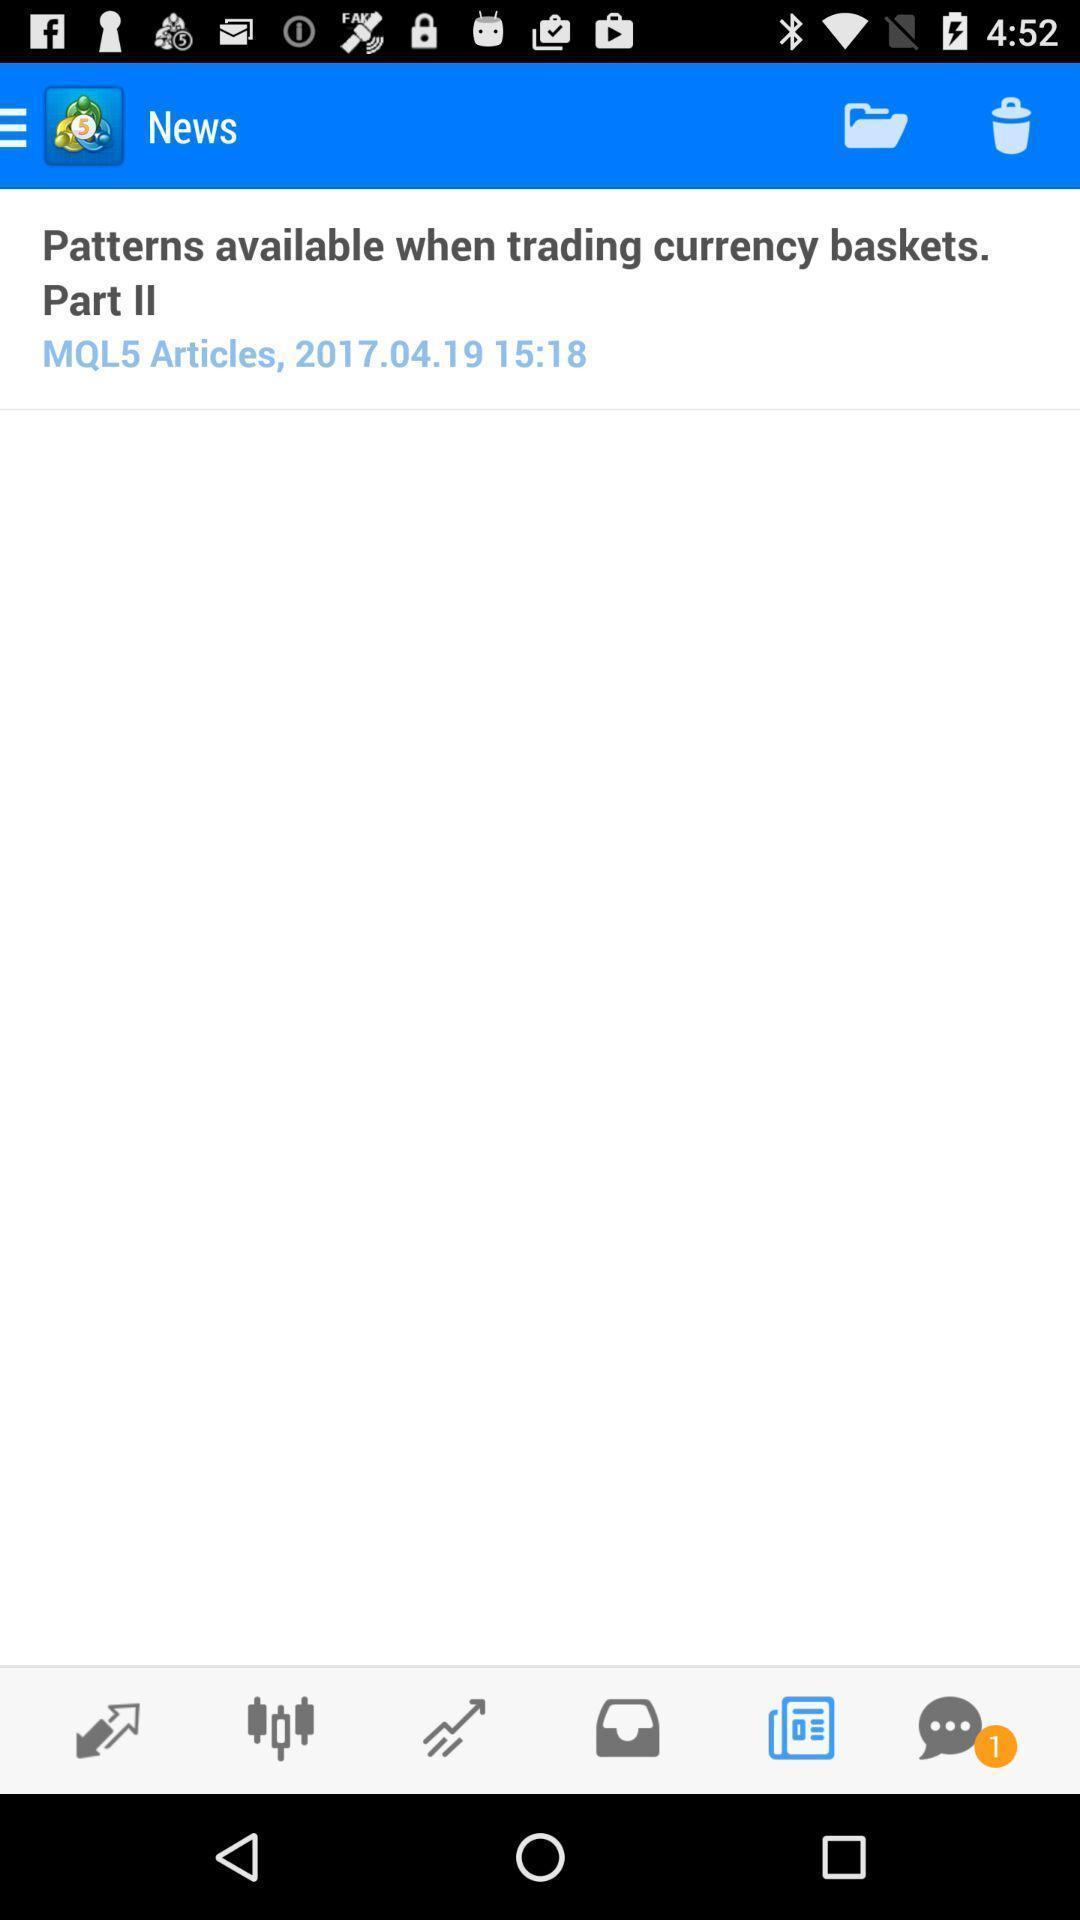Please provide a description for this image. Page for editing the marketing prices using charts. 